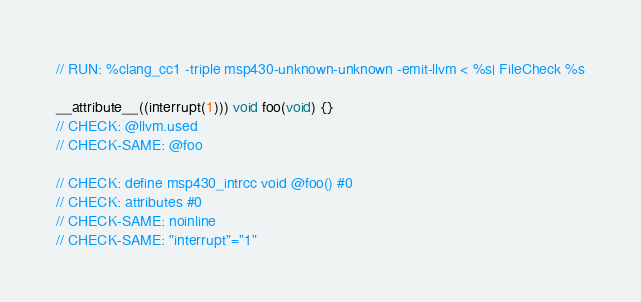<code> <loc_0><loc_0><loc_500><loc_500><_C_>// RUN: %clang_cc1 -triple msp430-unknown-unknown -emit-llvm < %s| FileCheck %s

__attribute__((interrupt(1))) void foo(void) {}
// CHECK: @llvm.used
// CHECK-SAME: @foo

// CHECK: define msp430_intrcc void @foo() #0
// CHECK: attributes #0
// CHECK-SAME: noinline
// CHECK-SAME: "interrupt"="1"
</code> 